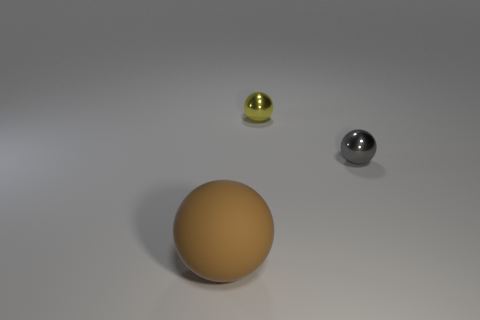There is a metal thing that is in front of the small yellow metallic object; how many metallic things are left of it?
Offer a very short reply. 1. There is a big matte ball; is its color the same as the shiny ball left of the small gray metal sphere?
Offer a terse response. No. There is another sphere that is the same size as the yellow ball; what is its color?
Offer a very short reply. Gray. Are there any gray things of the same shape as the yellow metal thing?
Your response must be concise. Yes. Are there fewer gray things than tiny balls?
Offer a very short reply. Yes. There is a metal ball right of the yellow object; what is its color?
Provide a succinct answer. Gray. Do the yellow ball and the brown thing that is in front of the yellow sphere have the same material?
Make the answer very short. No. What number of brown matte spheres are the same size as the brown thing?
Ensure brevity in your answer.  0. Is the number of yellow objects that are to the left of the brown rubber object less than the number of shiny spheres?
Offer a very short reply. Yes. What number of large brown balls are on the left side of the brown object?
Provide a short and direct response. 0. 